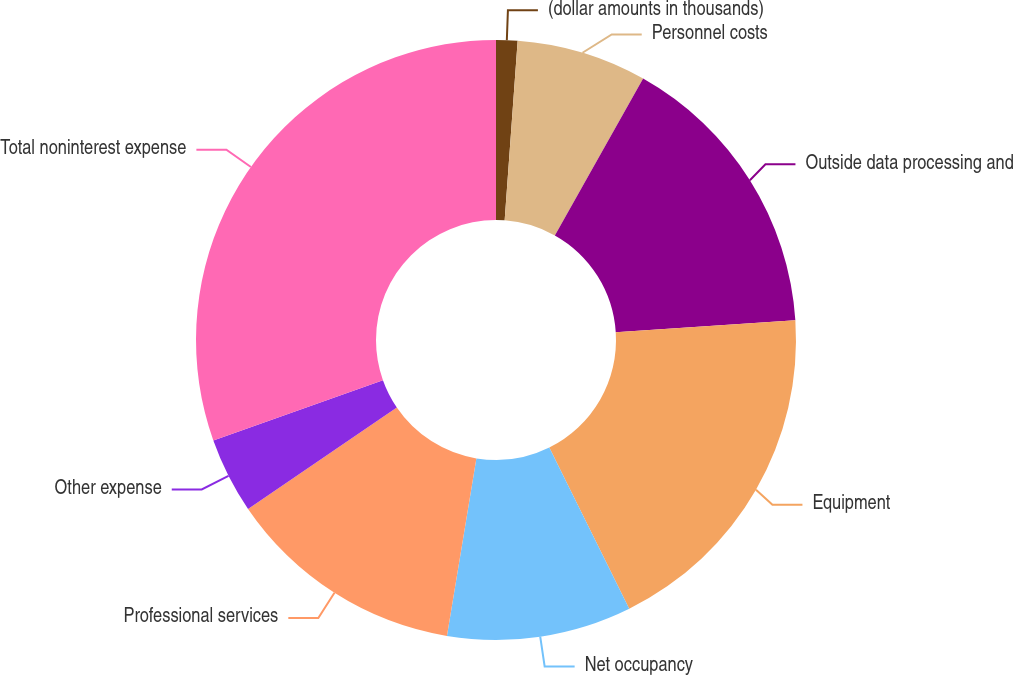Convert chart to OTSL. <chart><loc_0><loc_0><loc_500><loc_500><pie_chart><fcel>(dollar amounts in thousands)<fcel>Personnel costs<fcel>Outside data processing and<fcel>Equipment<fcel>Net occupancy<fcel>Professional services<fcel>Other expense<fcel>Total noninterest expense<nl><fcel>1.15%<fcel>7.01%<fcel>15.8%<fcel>18.72%<fcel>9.94%<fcel>12.87%<fcel>4.08%<fcel>30.44%<nl></chart> 